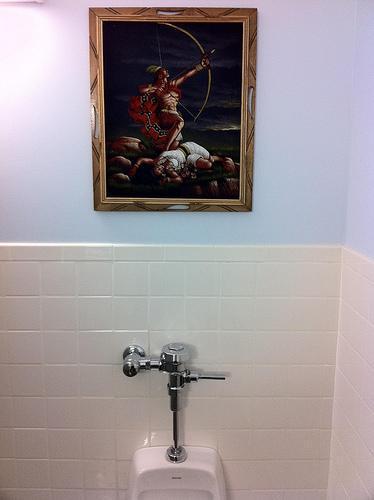How many urinals are in this photo?
Give a very brief answer. 1. How many people in the painting are laying down?
Give a very brief answer. 1. 